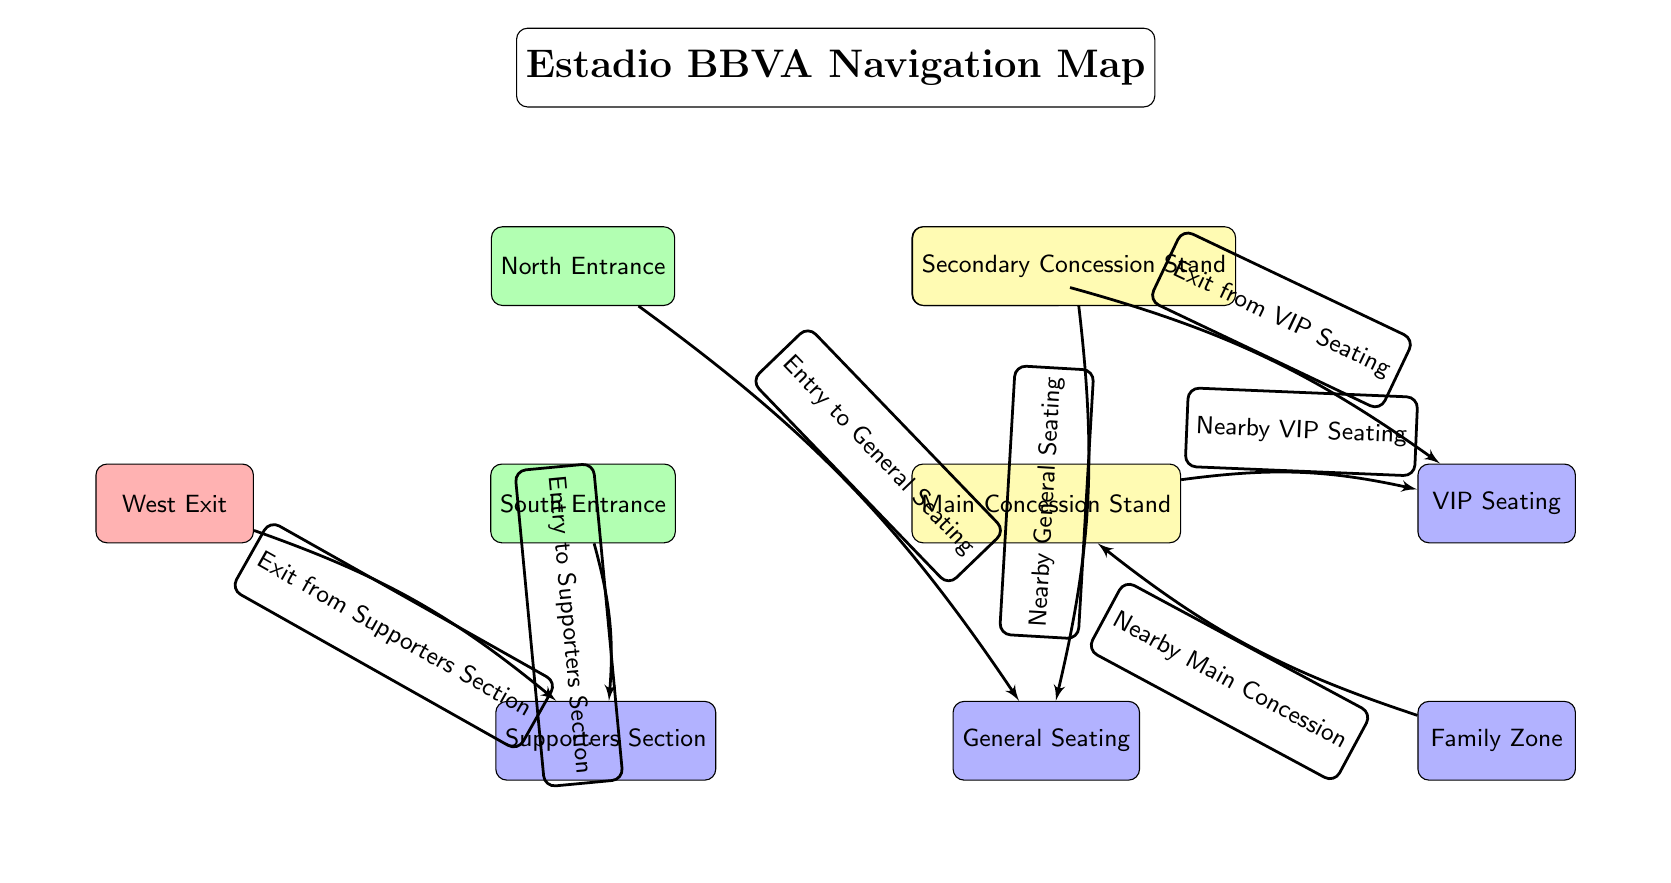What color is the North Entrance? The North Entrance is styled with the 'entrance' formatting, which specifies a green fill color. Therefore, the color of the North Entrance is green.
Answer: green How many concession stands are there? The diagram shows two nodes labeled as concession stands: Main Concession Stand and Secondary Concession Stand. Therefore, there are two concession stands.
Answer: 2 What sections can be accessed from the South Entrance? According to the edges, the South Entrance connects to the Supporters Section. Thus, the only section accessible from the South Entrance is the Supporters Section.
Answer: Supporters Section Which exit is connected to the VIP Seating? The East Exit is indicated in the diagram to be connected to VIP Seating based on the edge labeled "Exit from VIP Seating". Therefore, the exit connected to the VIP Seating is the East Exit.
Answer: East Exit What is located directly below the Main Concession Stand? The diagram displays that directly below the Main Concession Stand is the General Seating section. Hence, the section located directly below the Main Concession Stand is General Seating.
Answer: General Seating What is the relationship between the East Exit and the VIP Seating? The edge between the East Exit and VIP Seating is labeled "Exit from VIP Seating"; this indicates that the East Exit serves as a pathway to exit from the VIP Seating area. Thus, the relationship is that the East Exit is an exit for VIP Seating.
Answer: Exit from VIP Seating Is there any seating related to family near the Main Concession? The diagram illustrates that the Family Zone is positioned below the VIP Seating, and the Main Concession is to the right, implying that they are nearby. However, the diagram specifies that the Family Zone is "Nearby Main Concession," confirming its proximity. Thus, there is seating related to family near the Main Concession.
Answer: Yes How many exits are there in total in this diagram? The diagram indicates two exits: East Exit and West Exit. Thus, the total number of exits in this diagram is two.
Answer: 2 What section is directly accessed from the North Entrance? The edge from the North Entrance specifically states "Entry to General Seating," indicating that General Seating is directly accessed from the North Entrance. Thus, the section directly accessed from the North Entrance is General Seating.
Answer: General Seating 